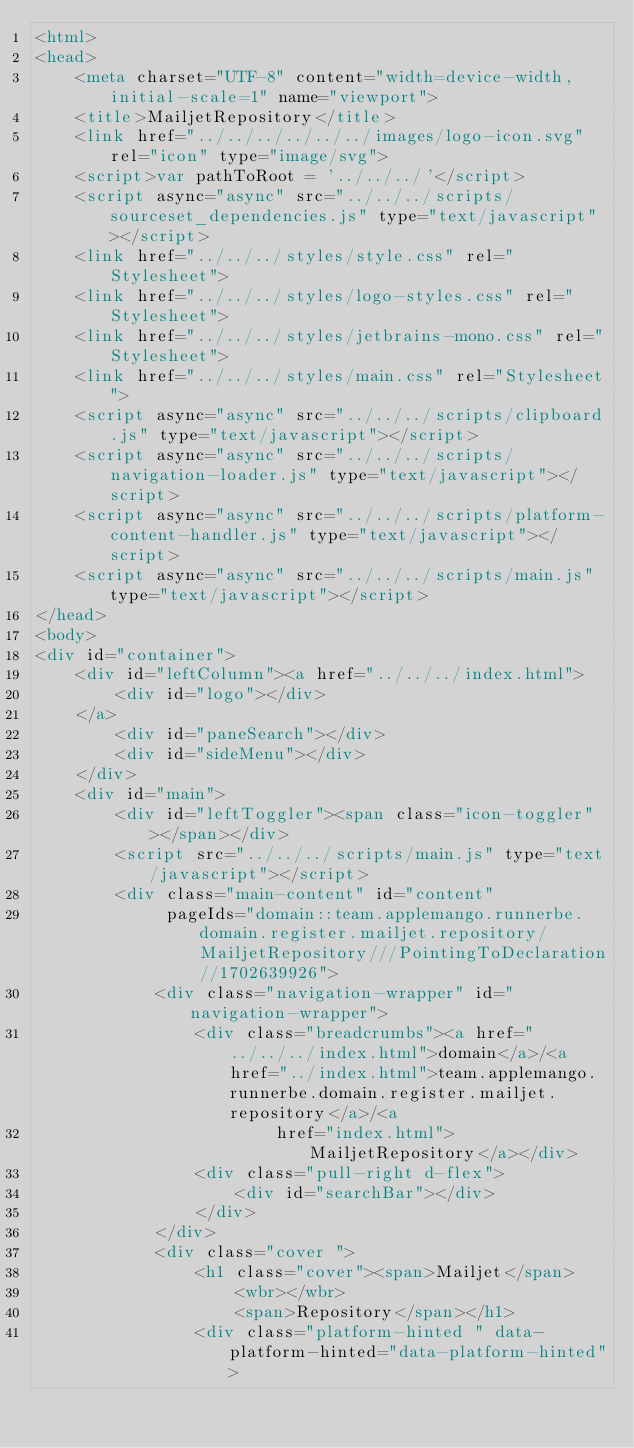Convert code to text. <code><loc_0><loc_0><loc_500><loc_500><_HTML_><html>
<head>
    <meta charset="UTF-8" content="width=device-width, initial-scale=1" name="viewport">
    <title>MailjetRepository</title>
    <link href="../../../../../../images/logo-icon.svg" rel="icon" type="image/svg">
    <script>var pathToRoot = '../../../'</script>
    <script async="async" src="../../../scripts/sourceset_dependencies.js" type="text/javascript"></script>
    <link href="../../../styles/style.css" rel="Stylesheet">
    <link href="../../../styles/logo-styles.css" rel="Stylesheet">
    <link href="../../../styles/jetbrains-mono.css" rel="Stylesheet">
    <link href="../../../styles/main.css" rel="Stylesheet">
    <script async="async" src="../../../scripts/clipboard.js" type="text/javascript"></script>
    <script async="async" src="../../../scripts/navigation-loader.js" type="text/javascript"></script>
    <script async="async" src="../../../scripts/platform-content-handler.js" type="text/javascript"></script>
    <script async="async" src="../../../scripts/main.js" type="text/javascript"></script>
</head>
<body>
<div id="container">
    <div id="leftColumn"><a href="../../../index.html">
        <div id="logo"></div>
    </a>
        <div id="paneSearch"></div>
        <div id="sideMenu"></div>
    </div>
    <div id="main">
        <div id="leftToggler"><span class="icon-toggler"></span></div>
        <script src="../../../scripts/main.js" type="text/javascript"></script>
        <div class="main-content" id="content"
             pageIds="domain::team.applemango.runnerbe.domain.register.mailjet.repository/MailjetRepository///PointingToDeclaration//1702639926">
            <div class="navigation-wrapper" id="navigation-wrapper">
                <div class="breadcrumbs"><a href="../../../index.html">domain</a>/<a href="../index.html">team.applemango.runnerbe.domain.register.mailjet.repository</a>/<a
                        href="index.html">MailjetRepository</a></div>
                <div class="pull-right d-flex">
                    <div id="searchBar"></div>
                </div>
            </div>
            <div class="cover ">
                <h1 class="cover"><span>Mailjet</span>
                    <wbr></wbr>
                    <span>Repository</span></h1>
                <div class="platform-hinted " data-platform-hinted="data-platform-hinted"></code> 